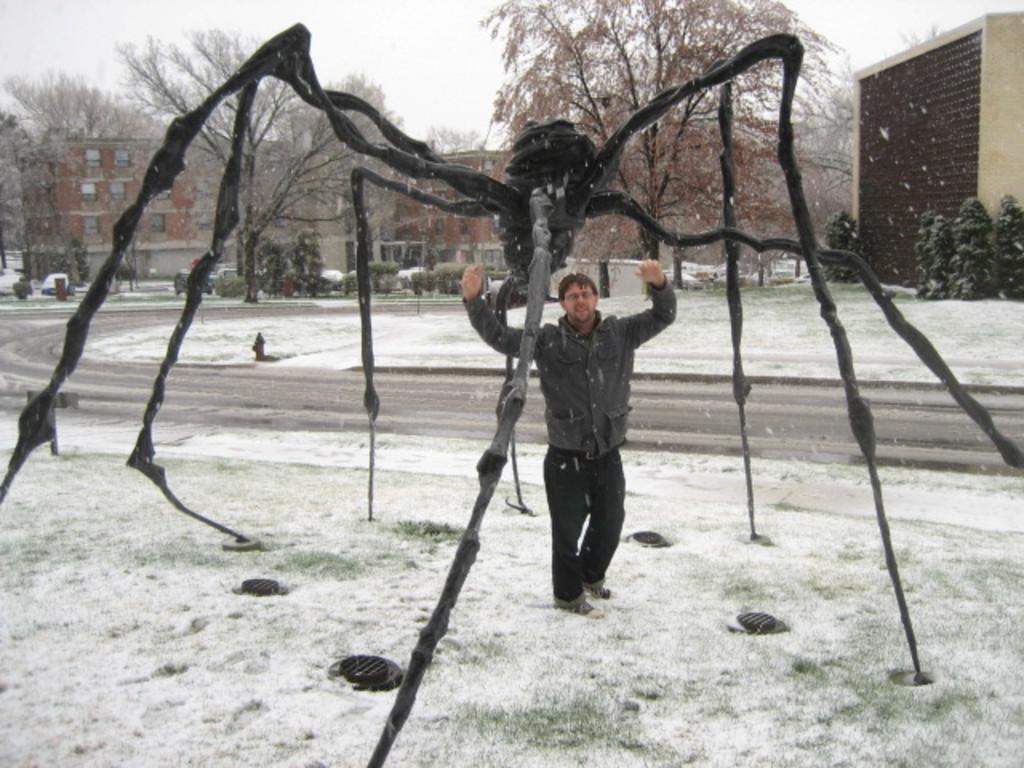Could you give a brief overview of what you see in this image? There is a person, snow and a model of an insect in the foreground area of the image, there are vehicles, trees, buildings and the sky in the background. 